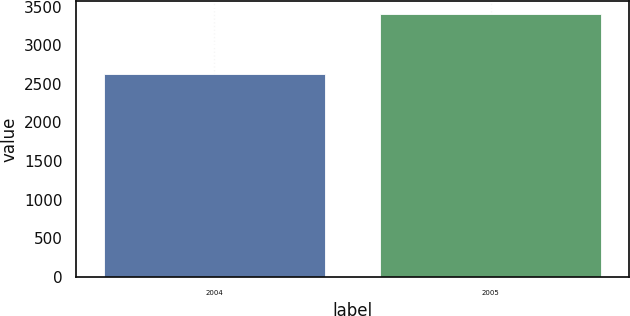Convert chart. <chart><loc_0><loc_0><loc_500><loc_500><bar_chart><fcel>2004<fcel>2005<nl><fcel>2630<fcel>3403<nl></chart> 